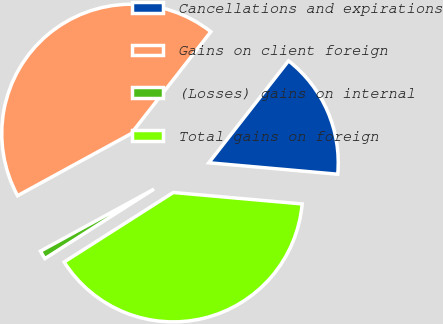Convert chart. <chart><loc_0><loc_0><loc_500><loc_500><pie_chart><fcel>Cancellations and expirations<fcel>Gains on client foreign<fcel>(Losses) gains on internal<fcel>Total gains on foreign<nl><fcel>15.85%<fcel>43.52%<fcel>1.07%<fcel>39.56%<nl></chart> 